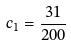<formula> <loc_0><loc_0><loc_500><loc_500>c _ { 1 } = { \frac { 3 1 } { 2 0 0 } }</formula> 